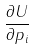<formula> <loc_0><loc_0><loc_500><loc_500>\frac { \partial U } { \partial p _ { i } }</formula> 